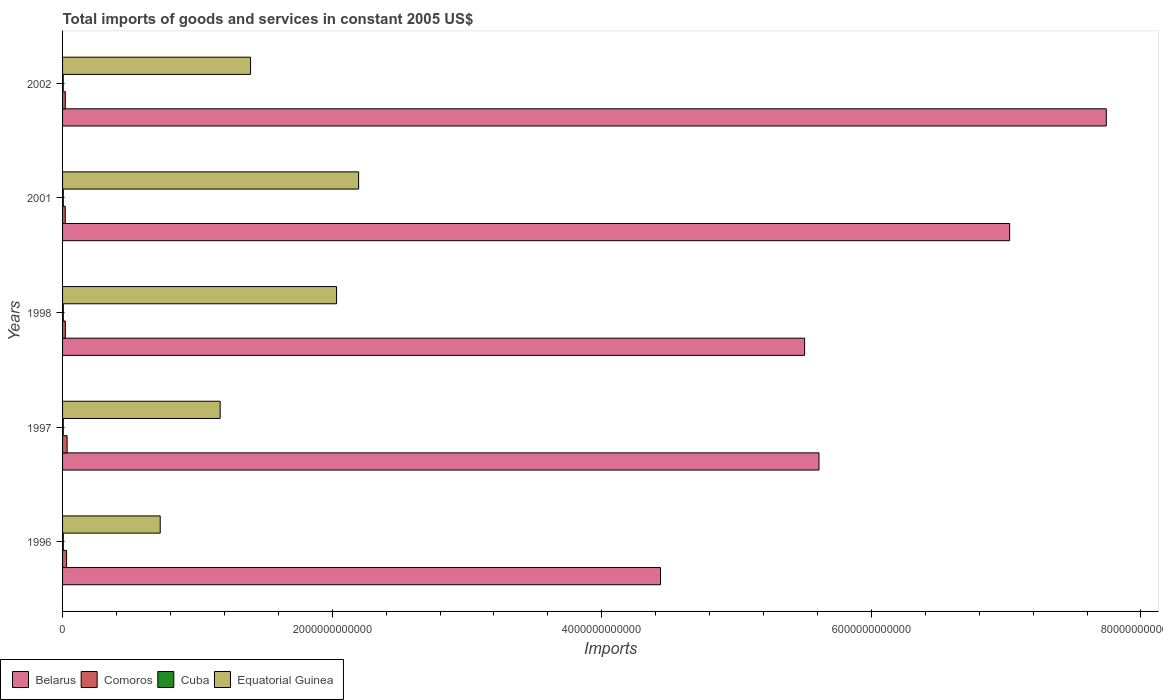How many groups of bars are there?
Your answer should be very brief. 5. Are the number of bars on each tick of the Y-axis equal?
Offer a terse response. Yes. How many bars are there on the 4th tick from the top?
Your answer should be compact. 4. What is the label of the 3rd group of bars from the top?
Your answer should be compact. 1998. What is the total imports of goods and services in Cuba in 2002?
Your answer should be compact. 4.91e+09. Across all years, what is the maximum total imports of goods and services in Cuba?
Offer a very short reply. 5.41e+09. Across all years, what is the minimum total imports of goods and services in Comoros?
Give a very brief answer. 2.00e+1. In which year was the total imports of goods and services in Cuba minimum?
Make the answer very short. 2002. What is the total total imports of goods and services in Belarus in the graph?
Provide a succinct answer. 3.03e+13. What is the difference between the total imports of goods and services in Comoros in 1996 and that in 1998?
Provide a short and direct response. 9.13e+09. What is the difference between the total imports of goods and services in Belarus in 1997 and the total imports of goods and services in Equatorial Guinea in 1998?
Provide a succinct answer. 3.58e+12. What is the average total imports of goods and services in Equatorial Guinea per year?
Offer a very short reply. 1.50e+12. In the year 1997, what is the difference between the total imports of goods and services in Cuba and total imports of goods and services in Equatorial Guinea?
Provide a succinct answer. -1.16e+12. What is the ratio of the total imports of goods and services in Cuba in 1997 to that in 2002?
Offer a very short reply. 1.08. What is the difference between the highest and the second highest total imports of goods and services in Equatorial Guinea?
Your answer should be compact. 1.64e+11. What is the difference between the highest and the lowest total imports of goods and services in Equatorial Guinea?
Provide a succinct answer. 1.47e+12. Is the sum of the total imports of goods and services in Comoros in 1998 and 2002 greater than the maximum total imports of goods and services in Cuba across all years?
Ensure brevity in your answer.  Yes. Is it the case that in every year, the sum of the total imports of goods and services in Equatorial Guinea and total imports of goods and services in Cuba is greater than the sum of total imports of goods and services in Comoros and total imports of goods and services in Belarus?
Provide a succinct answer. No. What does the 2nd bar from the top in 1998 represents?
Your answer should be compact. Cuba. What does the 3rd bar from the bottom in 1998 represents?
Offer a terse response. Cuba. How many bars are there?
Provide a succinct answer. 20. What is the difference between two consecutive major ticks on the X-axis?
Your response must be concise. 2.00e+12. How are the legend labels stacked?
Keep it short and to the point. Horizontal. What is the title of the graph?
Offer a very short reply. Total imports of goods and services in constant 2005 US$. What is the label or title of the X-axis?
Offer a terse response. Imports. What is the Imports in Belarus in 1996?
Give a very brief answer. 4.44e+12. What is the Imports in Comoros in 1996?
Ensure brevity in your answer.  2.98e+1. What is the Imports in Cuba in 1996?
Offer a very short reply. 5.41e+09. What is the Imports in Equatorial Guinea in 1996?
Provide a succinct answer. 7.24e+11. What is the Imports of Belarus in 1997?
Provide a succinct answer. 5.61e+12. What is the Imports of Comoros in 1997?
Provide a short and direct response. 3.37e+1. What is the Imports of Cuba in 1997?
Provide a succinct answer. 5.31e+09. What is the Imports in Equatorial Guinea in 1997?
Provide a succinct answer. 1.17e+12. What is the Imports in Belarus in 1998?
Provide a short and direct response. 5.50e+12. What is the Imports in Comoros in 1998?
Offer a terse response. 2.06e+1. What is the Imports of Cuba in 1998?
Make the answer very short. 5.38e+09. What is the Imports in Equatorial Guinea in 1998?
Your answer should be compact. 2.03e+12. What is the Imports of Belarus in 2001?
Ensure brevity in your answer.  7.03e+12. What is the Imports in Comoros in 2001?
Provide a short and direct response. 2.00e+1. What is the Imports in Cuba in 2001?
Provide a short and direct response. 5.30e+09. What is the Imports in Equatorial Guinea in 2001?
Offer a terse response. 2.20e+12. What is the Imports of Belarus in 2002?
Make the answer very short. 7.74e+12. What is the Imports of Comoros in 2002?
Provide a short and direct response. 2.04e+1. What is the Imports in Cuba in 2002?
Provide a short and direct response. 4.91e+09. What is the Imports in Equatorial Guinea in 2002?
Your answer should be very brief. 1.39e+12. Across all years, what is the maximum Imports in Belarus?
Your answer should be very brief. 7.74e+12. Across all years, what is the maximum Imports in Comoros?
Your answer should be very brief. 3.37e+1. Across all years, what is the maximum Imports of Cuba?
Give a very brief answer. 5.41e+09. Across all years, what is the maximum Imports of Equatorial Guinea?
Your response must be concise. 2.20e+12. Across all years, what is the minimum Imports of Belarus?
Offer a terse response. 4.44e+12. Across all years, what is the minimum Imports of Comoros?
Your answer should be compact. 2.00e+1. Across all years, what is the minimum Imports in Cuba?
Make the answer very short. 4.91e+09. Across all years, what is the minimum Imports of Equatorial Guinea?
Make the answer very short. 7.24e+11. What is the total Imports of Belarus in the graph?
Your answer should be compact. 3.03e+13. What is the total Imports of Comoros in the graph?
Your answer should be very brief. 1.25e+11. What is the total Imports in Cuba in the graph?
Offer a very short reply. 2.63e+1. What is the total Imports in Equatorial Guinea in the graph?
Keep it short and to the point. 7.52e+12. What is the difference between the Imports in Belarus in 1996 and that in 1997?
Give a very brief answer. -1.18e+12. What is the difference between the Imports in Comoros in 1996 and that in 1997?
Your response must be concise. -3.94e+09. What is the difference between the Imports in Cuba in 1996 and that in 1997?
Provide a short and direct response. 1.01e+08. What is the difference between the Imports in Equatorial Guinea in 1996 and that in 1997?
Give a very brief answer. -4.45e+11. What is the difference between the Imports in Belarus in 1996 and that in 1998?
Offer a terse response. -1.07e+12. What is the difference between the Imports in Comoros in 1996 and that in 1998?
Your answer should be very brief. 9.13e+09. What is the difference between the Imports of Cuba in 1996 and that in 1998?
Provide a short and direct response. 2.77e+07. What is the difference between the Imports in Equatorial Guinea in 1996 and that in 1998?
Your answer should be compact. -1.31e+12. What is the difference between the Imports in Belarus in 1996 and that in 2001?
Your answer should be very brief. -2.59e+12. What is the difference between the Imports in Comoros in 1996 and that in 2001?
Your answer should be compact. 9.75e+09. What is the difference between the Imports in Cuba in 1996 and that in 2001?
Keep it short and to the point. 1.16e+08. What is the difference between the Imports of Equatorial Guinea in 1996 and that in 2001?
Offer a very short reply. -1.47e+12. What is the difference between the Imports of Belarus in 1996 and that in 2002?
Your answer should be compact. -3.31e+12. What is the difference between the Imports in Comoros in 1996 and that in 2002?
Provide a succinct answer. 9.37e+09. What is the difference between the Imports of Cuba in 1996 and that in 2002?
Ensure brevity in your answer.  5.02e+08. What is the difference between the Imports in Equatorial Guinea in 1996 and that in 2002?
Give a very brief answer. -6.70e+11. What is the difference between the Imports in Belarus in 1997 and that in 1998?
Your answer should be compact. 1.07e+11. What is the difference between the Imports in Comoros in 1997 and that in 1998?
Ensure brevity in your answer.  1.31e+1. What is the difference between the Imports in Cuba in 1997 and that in 1998?
Provide a succinct answer. -7.29e+07. What is the difference between the Imports of Equatorial Guinea in 1997 and that in 1998?
Provide a succinct answer. -8.64e+11. What is the difference between the Imports of Belarus in 1997 and that in 2001?
Keep it short and to the point. -1.41e+12. What is the difference between the Imports of Comoros in 1997 and that in 2001?
Your response must be concise. 1.37e+1. What is the difference between the Imports in Cuba in 1997 and that in 2001?
Ensure brevity in your answer.  1.49e+07. What is the difference between the Imports in Equatorial Guinea in 1997 and that in 2001?
Provide a short and direct response. -1.03e+12. What is the difference between the Imports of Belarus in 1997 and that in 2002?
Your answer should be very brief. -2.13e+12. What is the difference between the Imports of Comoros in 1997 and that in 2002?
Give a very brief answer. 1.33e+1. What is the difference between the Imports of Cuba in 1997 and that in 2002?
Provide a succinct answer. 4.02e+08. What is the difference between the Imports of Equatorial Guinea in 1997 and that in 2002?
Offer a very short reply. -2.26e+11. What is the difference between the Imports of Belarus in 1998 and that in 2001?
Provide a short and direct response. -1.52e+12. What is the difference between the Imports in Comoros in 1998 and that in 2001?
Offer a terse response. 6.24e+08. What is the difference between the Imports of Cuba in 1998 and that in 2001?
Your answer should be very brief. 8.78e+07. What is the difference between the Imports of Equatorial Guinea in 1998 and that in 2001?
Keep it short and to the point. -1.64e+11. What is the difference between the Imports of Belarus in 1998 and that in 2002?
Your response must be concise. -2.24e+12. What is the difference between the Imports of Comoros in 1998 and that in 2002?
Keep it short and to the point. 2.43e+08. What is the difference between the Imports of Cuba in 1998 and that in 2002?
Offer a very short reply. 4.75e+08. What is the difference between the Imports of Equatorial Guinea in 1998 and that in 2002?
Ensure brevity in your answer.  6.38e+11. What is the difference between the Imports in Belarus in 2001 and that in 2002?
Give a very brief answer. -7.17e+11. What is the difference between the Imports of Comoros in 2001 and that in 2002?
Your answer should be very brief. -3.82e+08. What is the difference between the Imports in Cuba in 2001 and that in 2002?
Keep it short and to the point. 3.87e+08. What is the difference between the Imports of Equatorial Guinea in 2001 and that in 2002?
Keep it short and to the point. 8.02e+11. What is the difference between the Imports of Belarus in 1996 and the Imports of Comoros in 1997?
Provide a succinct answer. 4.40e+12. What is the difference between the Imports in Belarus in 1996 and the Imports in Cuba in 1997?
Keep it short and to the point. 4.43e+12. What is the difference between the Imports in Belarus in 1996 and the Imports in Equatorial Guinea in 1997?
Make the answer very short. 3.27e+12. What is the difference between the Imports in Comoros in 1996 and the Imports in Cuba in 1997?
Keep it short and to the point. 2.45e+1. What is the difference between the Imports of Comoros in 1996 and the Imports of Equatorial Guinea in 1997?
Provide a short and direct response. -1.14e+12. What is the difference between the Imports of Cuba in 1996 and the Imports of Equatorial Guinea in 1997?
Your response must be concise. -1.16e+12. What is the difference between the Imports in Belarus in 1996 and the Imports in Comoros in 1998?
Your answer should be very brief. 4.42e+12. What is the difference between the Imports in Belarus in 1996 and the Imports in Cuba in 1998?
Offer a terse response. 4.43e+12. What is the difference between the Imports in Belarus in 1996 and the Imports in Equatorial Guinea in 1998?
Offer a very short reply. 2.40e+12. What is the difference between the Imports in Comoros in 1996 and the Imports in Cuba in 1998?
Your answer should be very brief. 2.44e+1. What is the difference between the Imports of Comoros in 1996 and the Imports of Equatorial Guinea in 1998?
Give a very brief answer. -2.00e+12. What is the difference between the Imports of Cuba in 1996 and the Imports of Equatorial Guinea in 1998?
Offer a terse response. -2.03e+12. What is the difference between the Imports of Belarus in 1996 and the Imports of Comoros in 2001?
Offer a very short reply. 4.42e+12. What is the difference between the Imports of Belarus in 1996 and the Imports of Cuba in 2001?
Make the answer very short. 4.43e+12. What is the difference between the Imports of Belarus in 1996 and the Imports of Equatorial Guinea in 2001?
Offer a very short reply. 2.24e+12. What is the difference between the Imports of Comoros in 1996 and the Imports of Cuba in 2001?
Provide a short and direct response. 2.45e+1. What is the difference between the Imports of Comoros in 1996 and the Imports of Equatorial Guinea in 2001?
Offer a very short reply. -2.17e+12. What is the difference between the Imports in Cuba in 1996 and the Imports in Equatorial Guinea in 2001?
Ensure brevity in your answer.  -2.19e+12. What is the difference between the Imports in Belarus in 1996 and the Imports in Comoros in 2002?
Provide a short and direct response. 4.42e+12. What is the difference between the Imports of Belarus in 1996 and the Imports of Cuba in 2002?
Offer a terse response. 4.43e+12. What is the difference between the Imports of Belarus in 1996 and the Imports of Equatorial Guinea in 2002?
Ensure brevity in your answer.  3.04e+12. What is the difference between the Imports in Comoros in 1996 and the Imports in Cuba in 2002?
Ensure brevity in your answer.  2.49e+1. What is the difference between the Imports of Comoros in 1996 and the Imports of Equatorial Guinea in 2002?
Ensure brevity in your answer.  -1.36e+12. What is the difference between the Imports in Cuba in 1996 and the Imports in Equatorial Guinea in 2002?
Your response must be concise. -1.39e+12. What is the difference between the Imports in Belarus in 1997 and the Imports in Comoros in 1998?
Your answer should be compact. 5.59e+12. What is the difference between the Imports in Belarus in 1997 and the Imports in Cuba in 1998?
Keep it short and to the point. 5.61e+12. What is the difference between the Imports in Belarus in 1997 and the Imports in Equatorial Guinea in 1998?
Provide a succinct answer. 3.58e+12. What is the difference between the Imports of Comoros in 1997 and the Imports of Cuba in 1998?
Keep it short and to the point. 2.83e+1. What is the difference between the Imports of Comoros in 1997 and the Imports of Equatorial Guinea in 1998?
Your response must be concise. -2.00e+12. What is the difference between the Imports of Cuba in 1997 and the Imports of Equatorial Guinea in 1998?
Your answer should be very brief. -2.03e+12. What is the difference between the Imports of Belarus in 1997 and the Imports of Comoros in 2001?
Give a very brief answer. 5.59e+12. What is the difference between the Imports of Belarus in 1997 and the Imports of Cuba in 2001?
Your response must be concise. 5.61e+12. What is the difference between the Imports in Belarus in 1997 and the Imports in Equatorial Guinea in 2001?
Keep it short and to the point. 3.42e+12. What is the difference between the Imports in Comoros in 1997 and the Imports in Cuba in 2001?
Ensure brevity in your answer.  2.84e+1. What is the difference between the Imports in Comoros in 1997 and the Imports in Equatorial Guinea in 2001?
Provide a succinct answer. -2.16e+12. What is the difference between the Imports in Cuba in 1997 and the Imports in Equatorial Guinea in 2001?
Your answer should be very brief. -2.19e+12. What is the difference between the Imports in Belarus in 1997 and the Imports in Comoros in 2002?
Give a very brief answer. 5.59e+12. What is the difference between the Imports in Belarus in 1997 and the Imports in Cuba in 2002?
Make the answer very short. 5.61e+12. What is the difference between the Imports of Belarus in 1997 and the Imports of Equatorial Guinea in 2002?
Provide a succinct answer. 4.22e+12. What is the difference between the Imports in Comoros in 1997 and the Imports in Cuba in 2002?
Make the answer very short. 2.88e+1. What is the difference between the Imports in Comoros in 1997 and the Imports in Equatorial Guinea in 2002?
Your answer should be compact. -1.36e+12. What is the difference between the Imports of Cuba in 1997 and the Imports of Equatorial Guinea in 2002?
Your response must be concise. -1.39e+12. What is the difference between the Imports in Belarus in 1998 and the Imports in Comoros in 2001?
Your answer should be compact. 5.48e+12. What is the difference between the Imports of Belarus in 1998 and the Imports of Cuba in 2001?
Keep it short and to the point. 5.50e+12. What is the difference between the Imports of Belarus in 1998 and the Imports of Equatorial Guinea in 2001?
Offer a terse response. 3.31e+12. What is the difference between the Imports of Comoros in 1998 and the Imports of Cuba in 2001?
Keep it short and to the point. 1.53e+1. What is the difference between the Imports in Comoros in 1998 and the Imports in Equatorial Guinea in 2001?
Your response must be concise. -2.18e+12. What is the difference between the Imports in Cuba in 1998 and the Imports in Equatorial Guinea in 2001?
Your response must be concise. -2.19e+12. What is the difference between the Imports of Belarus in 1998 and the Imports of Comoros in 2002?
Ensure brevity in your answer.  5.48e+12. What is the difference between the Imports in Belarus in 1998 and the Imports in Cuba in 2002?
Keep it short and to the point. 5.50e+12. What is the difference between the Imports of Belarus in 1998 and the Imports of Equatorial Guinea in 2002?
Your response must be concise. 4.11e+12. What is the difference between the Imports of Comoros in 1998 and the Imports of Cuba in 2002?
Your answer should be very brief. 1.57e+1. What is the difference between the Imports in Comoros in 1998 and the Imports in Equatorial Guinea in 2002?
Your answer should be compact. -1.37e+12. What is the difference between the Imports in Cuba in 1998 and the Imports in Equatorial Guinea in 2002?
Make the answer very short. -1.39e+12. What is the difference between the Imports in Belarus in 2001 and the Imports in Comoros in 2002?
Your answer should be compact. 7.01e+12. What is the difference between the Imports of Belarus in 2001 and the Imports of Cuba in 2002?
Offer a terse response. 7.02e+12. What is the difference between the Imports in Belarus in 2001 and the Imports in Equatorial Guinea in 2002?
Offer a terse response. 5.63e+12. What is the difference between the Imports in Comoros in 2001 and the Imports in Cuba in 2002?
Offer a very short reply. 1.51e+1. What is the difference between the Imports in Comoros in 2001 and the Imports in Equatorial Guinea in 2002?
Ensure brevity in your answer.  -1.37e+12. What is the difference between the Imports of Cuba in 2001 and the Imports of Equatorial Guinea in 2002?
Ensure brevity in your answer.  -1.39e+12. What is the average Imports of Belarus per year?
Provide a short and direct response. 6.06e+12. What is the average Imports of Comoros per year?
Your response must be concise. 2.49e+1. What is the average Imports of Cuba per year?
Provide a short and direct response. 5.26e+09. What is the average Imports in Equatorial Guinea per year?
Give a very brief answer. 1.50e+12. In the year 1996, what is the difference between the Imports of Belarus and Imports of Comoros?
Make the answer very short. 4.41e+12. In the year 1996, what is the difference between the Imports in Belarus and Imports in Cuba?
Your answer should be very brief. 4.43e+12. In the year 1996, what is the difference between the Imports in Belarus and Imports in Equatorial Guinea?
Keep it short and to the point. 3.71e+12. In the year 1996, what is the difference between the Imports in Comoros and Imports in Cuba?
Offer a terse response. 2.44e+1. In the year 1996, what is the difference between the Imports of Comoros and Imports of Equatorial Guinea?
Give a very brief answer. -6.95e+11. In the year 1996, what is the difference between the Imports of Cuba and Imports of Equatorial Guinea?
Your response must be concise. -7.19e+11. In the year 1997, what is the difference between the Imports in Belarus and Imports in Comoros?
Make the answer very short. 5.58e+12. In the year 1997, what is the difference between the Imports of Belarus and Imports of Cuba?
Ensure brevity in your answer.  5.61e+12. In the year 1997, what is the difference between the Imports of Belarus and Imports of Equatorial Guinea?
Keep it short and to the point. 4.44e+12. In the year 1997, what is the difference between the Imports of Comoros and Imports of Cuba?
Provide a succinct answer. 2.84e+1. In the year 1997, what is the difference between the Imports in Comoros and Imports in Equatorial Guinea?
Make the answer very short. -1.14e+12. In the year 1997, what is the difference between the Imports in Cuba and Imports in Equatorial Guinea?
Keep it short and to the point. -1.16e+12. In the year 1998, what is the difference between the Imports of Belarus and Imports of Comoros?
Make the answer very short. 5.48e+12. In the year 1998, what is the difference between the Imports of Belarus and Imports of Cuba?
Your answer should be compact. 5.50e+12. In the year 1998, what is the difference between the Imports in Belarus and Imports in Equatorial Guinea?
Your response must be concise. 3.47e+12. In the year 1998, what is the difference between the Imports of Comoros and Imports of Cuba?
Keep it short and to the point. 1.53e+1. In the year 1998, what is the difference between the Imports in Comoros and Imports in Equatorial Guinea?
Keep it short and to the point. -2.01e+12. In the year 1998, what is the difference between the Imports in Cuba and Imports in Equatorial Guinea?
Provide a succinct answer. -2.03e+12. In the year 2001, what is the difference between the Imports of Belarus and Imports of Comoros?
Ensure brevity in your answer.  7.01e+12. In the year 2001, what is the difference between the Imports in Belarus and Imports in Cuba?
Make the answer very short. 7.02e+12. In the year 2001, what is the difference between the Imports in Belarus and Imports in Equatorial Guinea?
Give a very brief answer. 4.83e+12. In the year 2001, what is the difference between the Imports in Comoros and Imports in Cuba?
Your answer should be compact. 1.47e+1. In the year 2001, what is the difference between the Imports in Comoros and Imports in Equatorial Guinea?
Ensure brevity in your answer.  -2.18e+12. In the year 2001, what is the difference between the Imports of Cuba and Imports of Equatorial Guinea?
Provide a short and direct response. -2.19e+12. In the year 2002, what is the difference between the Imports in Belarus and Imports in Comoros?
Keep it short and to the point. 7.72e+12. In the year 2002, what is the difference between the Imports of Belarus and Imports of Cuba?
Offer a terse response. 7.74e+12. In the year 2002, what is the difference between the Imports in Belarus and Imports in Equatorial Guinea?
Your answer should be very brief. 6.35e+12. In the year 2002, what is the difference between the Imports of Comoros and Imports of Cuba?
Ensure brevity in your answer.  1.55e+1. In the year 2002, what is the difference between the Imports in Comoros and Imports in Equatorial Guinea?
Offer a very short reply. -1.37e+12. In the year 2002, what is the difference between the Imports in Cuba and Imports in Equatorial Guinea?
Your response must be concise. -1.39e+12. What is the ratio of the Imports in Belarus in 1996 to that in 1997?
Your answer should be very brief. 0.79. What is the ratio of the Imports of Comoros in 1996 to that in 1997?
Ensure brevity in your answer.  0.88. What is the ratio of the Imports in Cuba in 1996 to that in 1997?
Give a very brief answer. 1.02. What is the ratio of the Imports of Equatorial Guinea in 1996 to that in 1997?
Offer a very short reply. 0.62. What is the ratio of the Imports in Belarus in 1996 to that in 1998?
Give a very brief answer. 0.81. What is the ratio of the Imports in Comoros in 1996 to that in 1998?
Give a very brief answer. 1.44. What is the ratio of the Imports of Equatorial Guinea in 1996 to that in 1998?
Ensure brevity in your answer.  0.36. What is the ratio of the Imports of Belarus in 1996 to that in 2001?
Ensure brevity in your answer.  0.63. What is the ratio of the Imports of Comoros in 1996 to that in 2001?
Offer a terse response. 1.49. What is the ratio of the Imports of Cuba in 1996 to that in 2001?
Your answer should be compact. 1.02. What is the ratio of the Imports in Equatorial Guinea in 1996 to that in 2001?
Make the answer very short. 0.33. What is the ratio of the Imports in Belarus in 1996 to that in 2002?
Provide a succinct answer. 0.57. What is the ratio of the Imports in Comoros in 1996 to that in 2002?
Ensure brevity in your answer.  1.46. What is the ratio of the Imports in Cuba in 1996 to that in 2002?
Ensure brevity in your answer.  1.1. What is the ratio of the Imports in Equatorial Guinea in 1996 to that in 2002?
Give a very brief answer. 0.52. What is the ratio of the Imports in Belarus in 1997 to that in 1998?
Provide a succinct answer. 1.02. What is the ratio of the Imports in Comoros in 1997 to that in 1998?
Provide a succinct answer. 1.63. What is the ratio of the Imports in Cuba in 1997 to that in 1998?
Offer a very short reply. 0.99. What is the ratio of the Imports of Equatorial Guinea in 1997 to that in 1998?
Your answer should be compact. 0.58. What is the ratio of the Imports in Belarus in 1997 to that in 2001?
Your answer should be compact. 0.8. What is the ratio of the Imports of Comoros in 1997 to that in 2001?
Ensure brevity in your answer.  1.68. What is the ratio of the Imports in Cuba in 1997 to that in 2001?
Provide a short and direct response. 1. What is the ratio of the Imports in Equatorial Guinea in 1997 to that in 2001?
Provide a short and direct response. 0.53. What is the ratio of the Imports of Belarus in 1997 to that in 2002?
Your response must be concise. 0.72. What is the ratio of the Imports in Comoros in 1997 to that in 2002?
Give a very brief answer. 1.65. What is the ratio of the Imports in Cuba in 1997 to that in 2002?
Make the answer very short. 1.08. What is the ratio of the Imports in Equatorial Guinea in 1997 to that in 2002?
Offer a very short reply. 0.84. What is the ratio of the Imports in Belarus in 1998 to that in 2001?
Offer a very short reply. 0.78. What is the ratio of the Imports of Comoros in 1998 to that in 2001?
Provide a succinct answer. 1.03. What is the ratio of the Imports of Cuba in 1998 to that in 2001?
Your answer should be very brief. 1.02. What is the ratio of the Imports of Equatorial Guinea in 1998 to that in 2001?
Keep it short and to the point. 0.93. What is the ratio of the Imports in Belarus in 1998 to that in 2002?
Provide a succinct answer. 0.71. What is the ratio of the Imports of Comoros in 1998 to that in 2002?
Provide a succinct answer. 1.01. What is the ratio of the Imports of Cuba in 1998 to that in 2002?
Offer a terse response. 1.1. What is the ratio of the Imports in Equatorial Guinea in 1998 to that in 2002?
Ensure brevity in your answer.  1.46. What is the ratio of the Imports of Belarus in 2001 to that in 2002?
Your answer should be very brief. 0.91. What is the ratio of the Imports of Comoros in 2001 to that in 2002?
Provide a short and direct response. 0.98. What is the ratio of the Imports of Cuba in 2001 to that in 2002?
Your response must be concise. 1.08. What is the ratio of the Imports of Equatorial Guinea in 2001 to that in 2002?
Give a very brief answer. 1.57. What is the difference between the highest and the second highest Imports in Belarus?
Keep it short and to the point. 7.17e+11. What is the difference between the highest and the second highest Imports in Comoros?
Ensure brevity in your answer.  3.94e+09. What is the difference between the highest and the second highest Imports in Cuba?
Ensure brevity in your answer.  2.77e+07. What is the difference between the highest and the second highest Imports of Equatorial Guinea?
Provide a short and direct response. 1.64e+11. What is the difference between the highest and the lowest Imports of Belarus?
Provide a short and direct response. 3.31e+12. What is the difference between the highest and the lowest Imports in Comoros?
Your answer should be compact. 1.37e+1. What is the difference between the highest and the lowest Imports in Cuba?
Your answer should be compact. 5.02e+08. What is the difference between the highest and the lowest Imports of Equatorial Guinea?
Your answer should be very brief. 1.47e+12. 